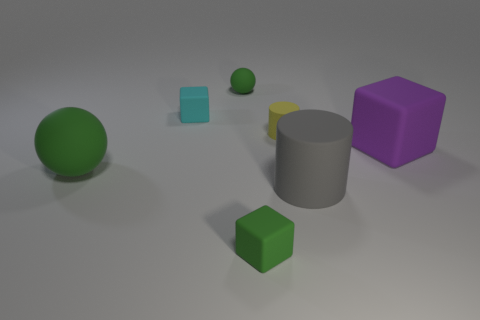Subtract all yellow cylinders. How many cylinders are left? 1 Subtract all small cubes. How many cubes are left? 1 Subtract 2 cubes. How many cubes are left? 1 Subtract all small gray matte spheres. Subtract all tiny yellow rubber objects. How many objects are left? 6 Add 2 cyan matte cubes. How many cyan matte cubes are left? 3 Add 4 large balls. How many large balls exist? 5 Add 1 big matte spheres. How many objects exist? 8 Subtract 1 gray cylinders. How many objects are left? 6 Subtract all cubes. How many objects are left? 4 Subtract all gray blocks. Subtract all brown spheres. How many blocks are left? 3 